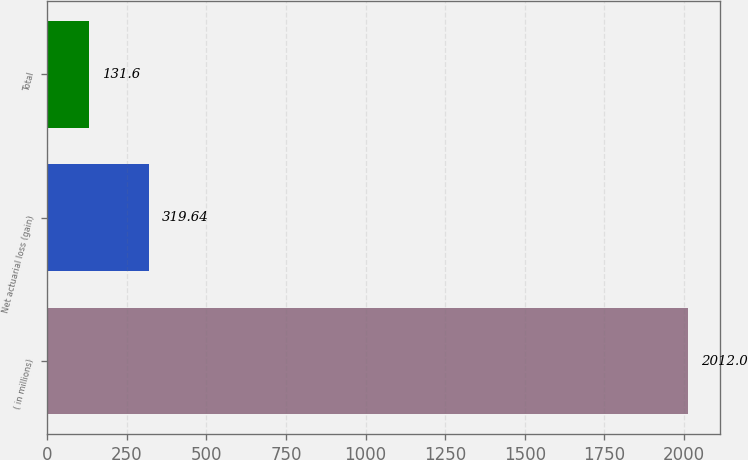Convert chart to OTSL. <chart><loc_0><loc_0><loc_500><loc_500><bar_chart><fcel>( in millions)<fcel>Net actuarial loss (gain)<fcel>Total<nl><fcel>2012<fcel>319.64<fcel>131.6<nl></chart> 